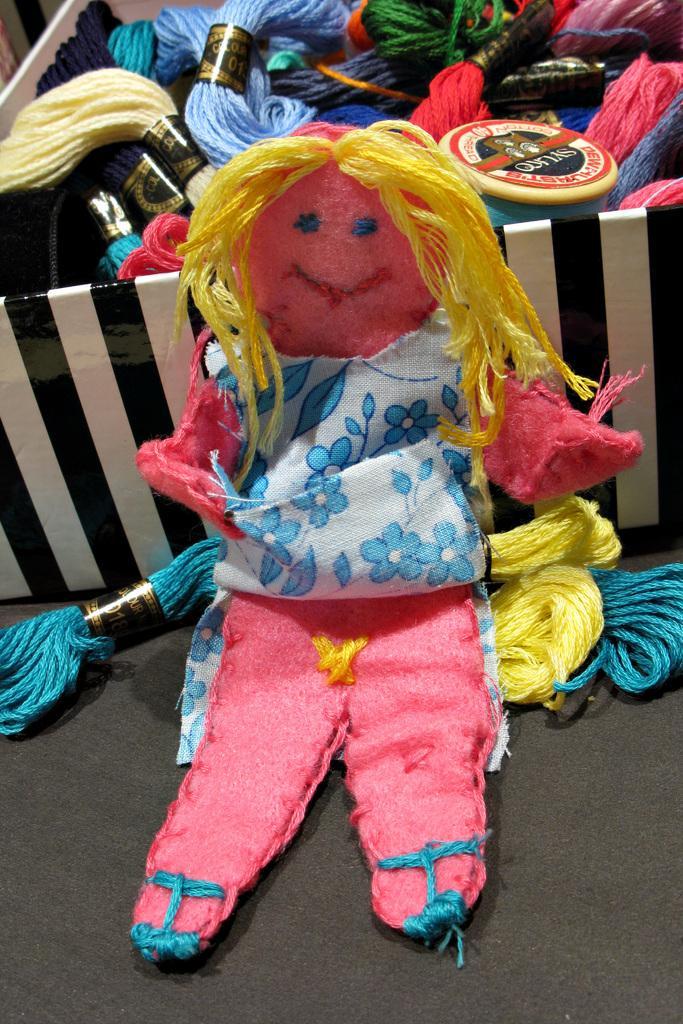In one or two sentences, can you explain what this image depicts? In the picture there is a doll present which is made of wool, behind the doll there is a box, in the box there are many wool rolls present. 